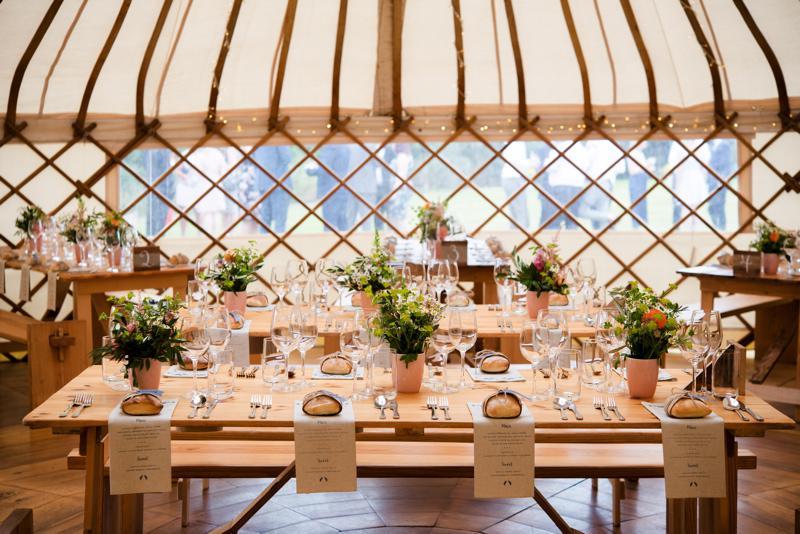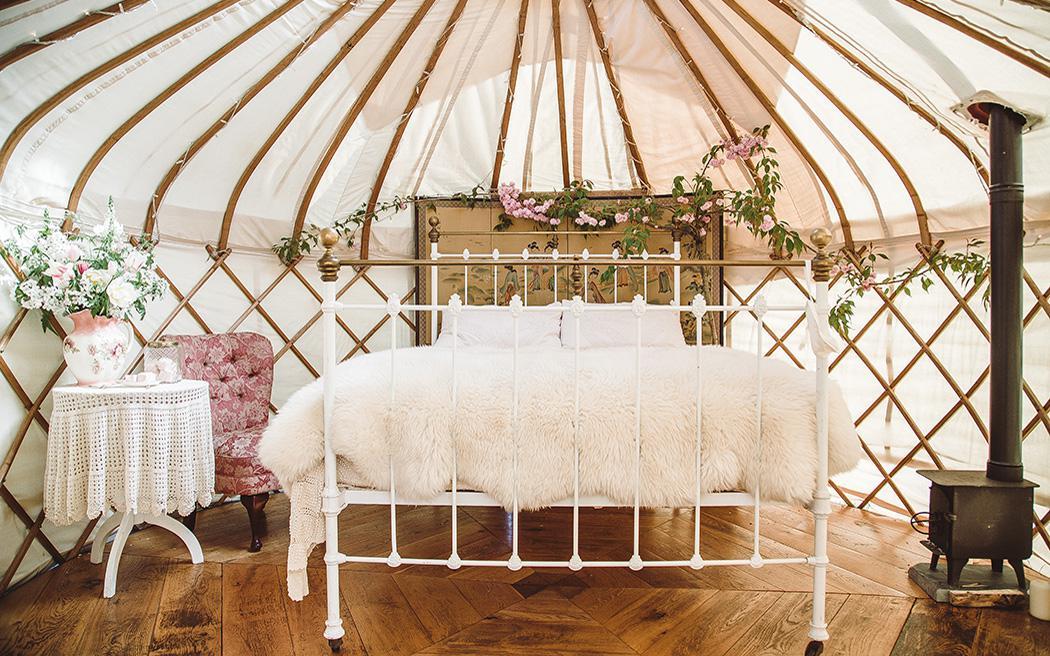The first image is the image on the left, the second image is the image on the right. Evaluate the accuracy of this statement regarding the images: "There is one bed in the image on the right.". Is it true? Answer yes or no. Yes. 